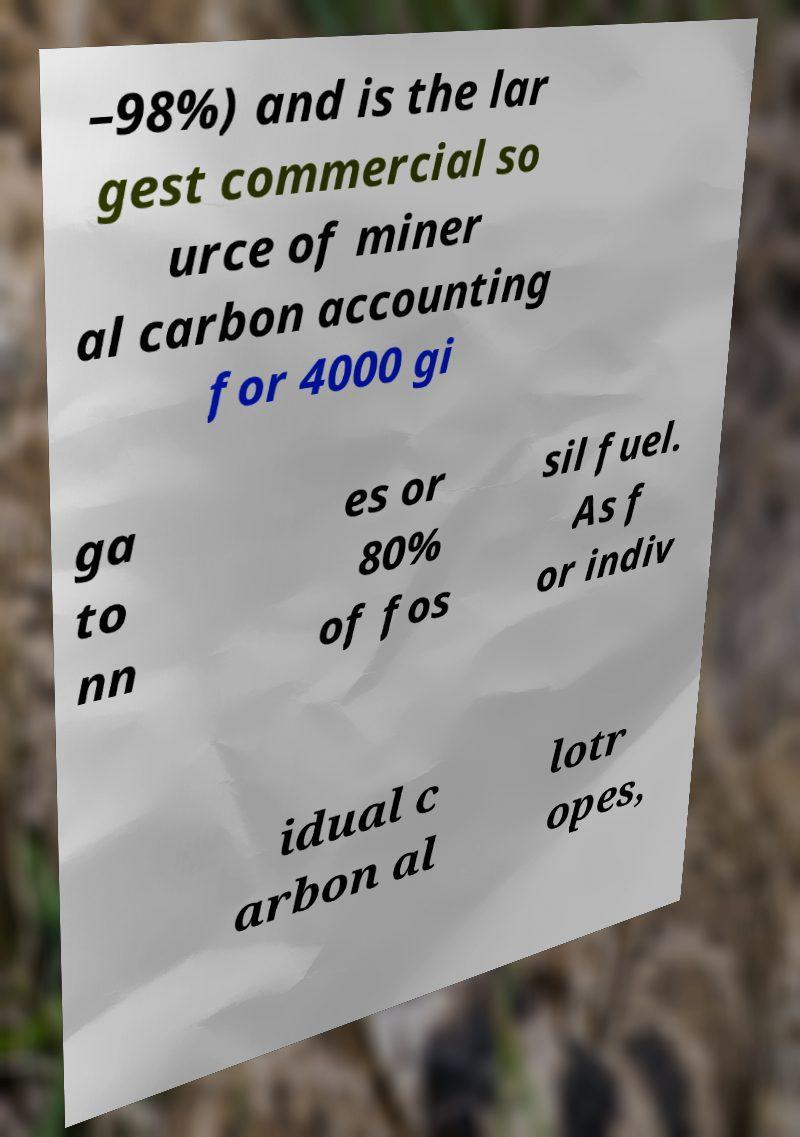There's text embedded in this image that I need extracted. Can you transcribe it verbatim? –98%) and is the lar gest commercial so urce of miner al carbon accounting for 4000 gi ga to nn es or 80% of fos sil fuel. As f or indiv idual c arbon al lotr opes, 